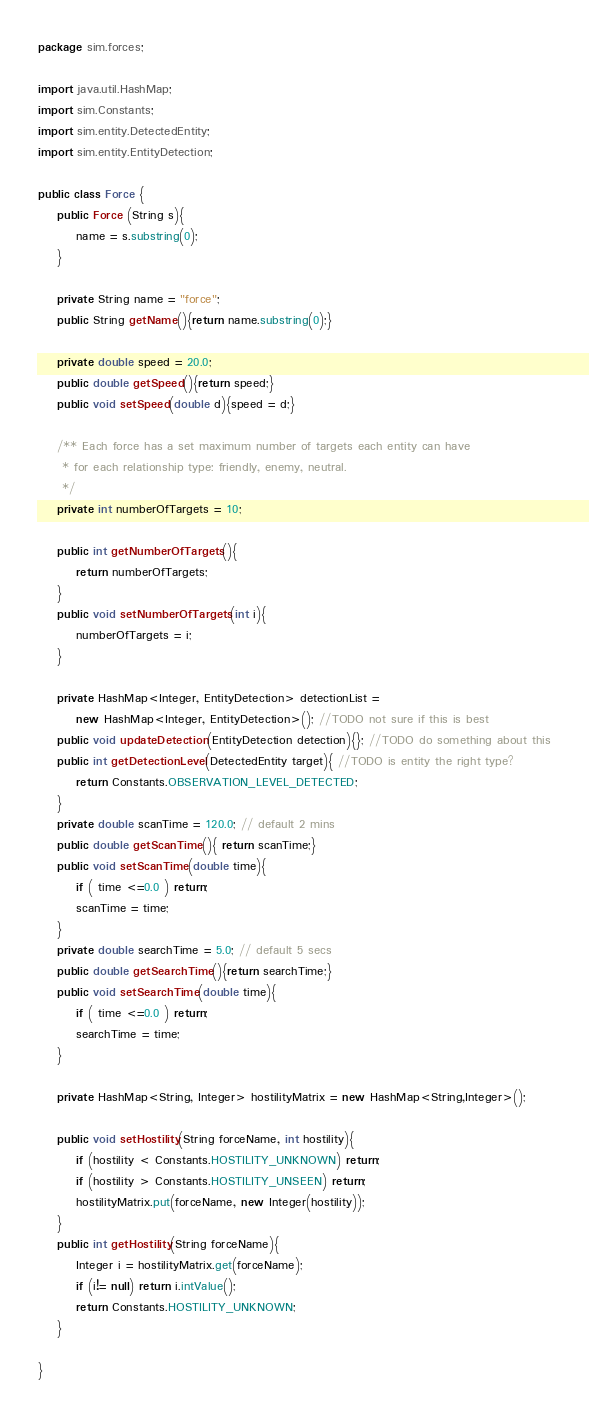Convert code to text. <code><loc_0><loc_0><loc_500><loc_500><_Java_>package sim.forces;

import java.util.HashMap;
import sim.Constants;
import sim.entity.DetectedEntity;
import sim.entity.EntityDetection;

public class Force {
	public Force (String s){
		name = s.substring(0);
	}
	
	private String name = "force";
	public String getName(){return name.substring(0);}
	
	private double speed = 20.0;
	public double getSpeed(){return speed;}
	public void setSpeed(double d){speed = d;}
	
	/** Each force has a set maximum number of targets each entity can have
	 * for each relationship type: friendly, enemy, neutral.
	 */
	private int numberOfTargets = 10;
	
	public int getNumberOfTargets(){
		return numberOfTargets;
	}
	public void setNumberOfTargets(int i){
		numberOfTargets = i; 
	}
	
	private HashMap<Integer, EntityDetection> detectionList = 
		new HashMap<Integer, EntityDetection>(); //TODO not sure if this is best
	public void updateDetection(EntityDetection detection){}; //TODO do something about this
	public int getDetectionLevel(DetectedEntity target){ //TODO is entity the right type?
		return Constants.OBSERVATION_LEVEL_DETECTED;
	}
	private double scanTime = 120.0; // default 2 mins
	public double getScanTime(){ return scanTime;}
	public void setScanTime(double time){
		if ( time <=0.0 ) return;
		scanTime = time;
	}
	private double searchTime = 5.0; // default 5 secs
	public double getSearchTime(){return searchTime;}
	public void setSearchTime(double time){
		if ( time <=0.0 ) return;
		searchTime = time;
	}

	private HashMap<String, Integer> hostilityMatrix = new HashMap<String,Integer>();

	public void setHostility(String forceName, int hostility){
		if (hostility < Constants.HOSTILITY_UNKNOWN) return;
		if (hostility > Constants.HOSTILITY_UNSEEN) return;
		hostilityMatrix.put(forceName, new Integer(hostility));
	}
	public int getHostility(String forceName){
		Integer i = hostilityMatrix.get(forceName);
		if (i!= null) return i.intValue();
		return Constants.HOSTILITY_UNKNOWN;
	}

}
</code> 